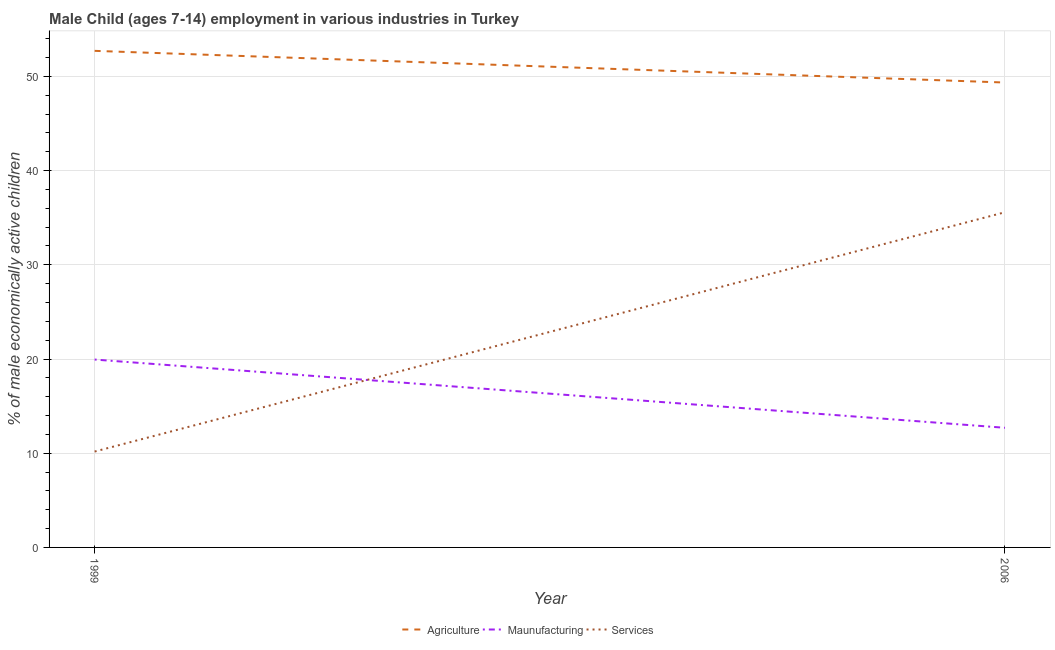How many different coloured lines are there?
Offer a very short reply. 3. Does the line corresponding to percentage of economically active children in manufacturing intersect with the line corresponding to percentage of economically active children in agriculture?
Make the answer very short. No. Is the number of lines equal to the number of legend labels?
Your answer should be very brief. Yes. What is the percentage of economically active children in services in 2006?
Keep it short and to the point. 35.58. Across all years, what is the maximum percentage of economically active children in manufacturing?
Make the answer very short. 19.94. Across all years, what is the minimum percentage of economically active children in services?
Provide a succinct answer. 10.18. In which year was the percentage of economically active children in services maximum?
Provide a succinct answer. 2006. What is the total percentage of economically active children in services in the graph?
Make the answer very short. 45.76. What is the difference between the percentage of economically active children in manufacturing in 1999 and that in 2006?
Provide a short and direct response. 7.24. What is the difference between the percentage of economically active children in manufacturing in 1999 and the percentage of economically active children in services in 2006?
Offer a very short reply. -15.64. What is the average percentage of economically active children in manufacturing per year?
Offer a very short reply. 16.32. In the year 1999, what is the difference between the percentage of economically active children in agriculture and percentage of economically active children in services?
Ensure brevity in your answer.  42.53. In how many years, is the percentage of economically active children in manufacturing greater than 46 %?
Offer a very short reply. 0. What is the ratio of the percentage of economically active children in agriculture in 1999 to that in 2006?
Your response must be concise. 1.07. Is the percentage of economically active children in manufacturing in 1999 less than that in 2006?
Your response must be concise. No. Does the percentage of economically active children in services monotonically increase over the years?
Offer a terse response. Yes. Is the percentage of economically active children in agriculture strictly greater than the percentage of economically active children in services over the years?
Your answer should be very brief. Yes. Is the percentage of economically active children in agriculture strictly less than the percentage of economically active children in manufacturing over the years?
Offer a terse response. No. Are the values on the major ticks of Y-axis written in scientific E-notation?
Offer a terse response. No. Does the graph contain any zero values?
Offer a very short reply. No. Does the graph contain grids?
Make the answer very short. Yes. Where does the legend appear in the graph?
Provide a succinct answer. Bottom center. How many legend labels are there?
Give a very brief answer. 3. How are the legend labels stacked?
Ensure brevity in your answer.  Horizontal. What is the title of the graph?
Make the answer very short. Male Child (ages 7-14) employment in various industries in Turkey. What is the label or title of the Y-axis?
Ensure brevity in your answer.  % of male economically active children. What is the % of male economically active children of Agriculture in 1999?
Make the answer very short. 52.71. What is the % of male economically active children of Maunufacturing in 1999?
Offer a very short reply. 19.94. What is the % of male economically active children in Services in 1999?
Ensure brevity in your answer.  10.18. What is the % of male economically active children in Agriculture in 2006?
Provide a short and direct response. 49.35. What is the % of male economically active children of Maunufacturing in 2006?
Give a very brief answer. 12.7. What is the % of male economically active children of Services in 2006?
Offer a terse response. 35.58. Across all years, what is the maximum % of male economically active children in Agriculture?
Your answer should be compact. 52.71. Across all years, what is the maximum % of male economically active children in Maunufacturing?
Make the answer very short. 19.94. Across all years, what is the maximum % of male economically active children in Services?
Offer a very short reply. 35.58. Across all years, what is the minimum % of male economically active children of Agriculture?
Give a very brief answer. 49.35. Across all years, what is the minimum % of male economically active children of Services?
Provide a succinct answer. 10.18. What is the total % of male economically active children of Agriculture in the graph?
Your response must be concise. 102.06. What is the total % of male economically active children in Maunufacturing in the graph?
Offer a very short reply. 32.64. What is the total % of male economically active children in Services in the graph?
Your answer should be very brief. 45.76. What is the difference between the % of male economically active children in Agriculture in 1999 and that in 2006?
Provide a succinct answer. 3.36. What is the difference between the % of male economically active children of Maunufacturing in 1999 and that in 2006?
Your answer should be compact. 7.24. What is the difference between the % of male economically active children in Services in 1999 and that in 2006?
Give a very brief answer. -25.4. What is the difference between the % of male economically active children of Agriculture in 1999 and the % of male economically active children of Maunufacturing in 2006?
Your response must be concise. 40.01. What is the difference between the % of male economically active children in Agriculture in 1999 and the % of male economically active children in Services in 2006?
Provide a succinct answer. 17.13. What is the difference between the % of male economically active children of Maunufacturing in 1999 and the % of male economically active children of Services in 2006?
Your answer should be compact. -15.64. What is the average % of male economically active children in Agriculture per year?
Provide a succinct answer. 51.03. What is the average % of male economically active children in Maunufacturing per year?
Offer a terse response. 16.32. What is the average % of male economically active children of Services per year?
Your answer should be very brief. 22.88. In the year 1999, what is the difference between the % of male economically active children in Agriculture and % of male economically active children in Maunufacturing?
Provide a succinct answer. 32.77. In the year 1999, what is the difference between the % of male economically active children of Agriculture and % of male economically active children of Services?
Your response must be concise. 42.53. In the year 1999, what is the difference between the % of male economically active children in Maunufacturing and % of male economically active children in Services?
Your answer should be compact. 9.77. In the year 2006, what is the difference between the % of male economically active children of Agriculture and % of male economically active children of Maunufacturing?
Make the answer very short. 36.65. In the year 2006, what is the difference between the % of male economically active children of Agriculture and % of male economically active children of Services?
Your response must be concise. 13.77. In the year 2006, what is the difference between the % of male economically active children in Maunufacturing and % of male economically active children in Services?
Make the answer very short. -22.88. What is the ratio of the % of male economically active children in Agriculture in 1999 to that in 2006?
Offer a very short reply. 1.07. What is the ratio of the % of male economically active children in Maunufacturing in 1999 to that in 2006?
Provide a succinct answer. 1.57. What is the ratio of the % of male economically active children of Services in 1999 to that in 2006?
Give a very brief answer. 0.29. What is the difference between the highest and the second highest % of male economically active children of Agriculture?
Offer a very short reply. 3.36. What is the difference between the highest and the second highest % of male economically active children in Maunufacturing?
Give a very brief answer. 7.24. What is the difference between the highest and the second highest % of male economically active children in Services?
Keep it short and to the point. 25.4. What is the difference between the highest and the lowest % of male economically active children in Agriculture?
Your response must be concise. 3.36. What is the difference between the highest and the lowest % of male economically active children in Maunufacturing?
Make the answer very short. 7.24. What is the difference between the highest and the lowest % of male economically active children of Services?
Provide a succinct answer. 25.4. 